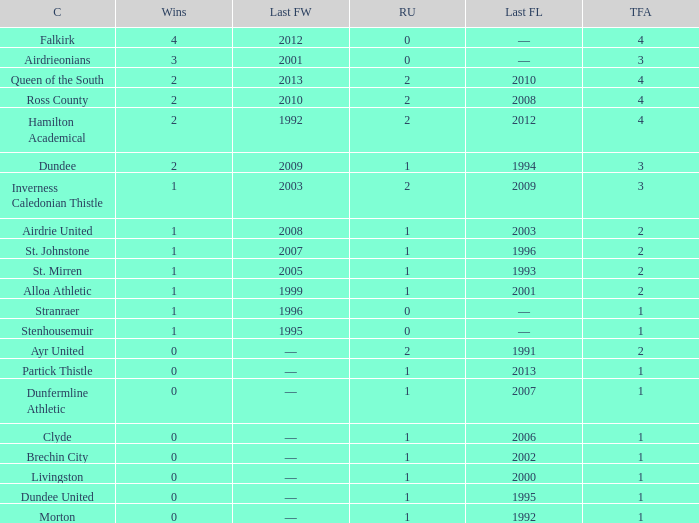How manywins for dunfermline athletic that has a total final appearances less than 2? 0.0. 